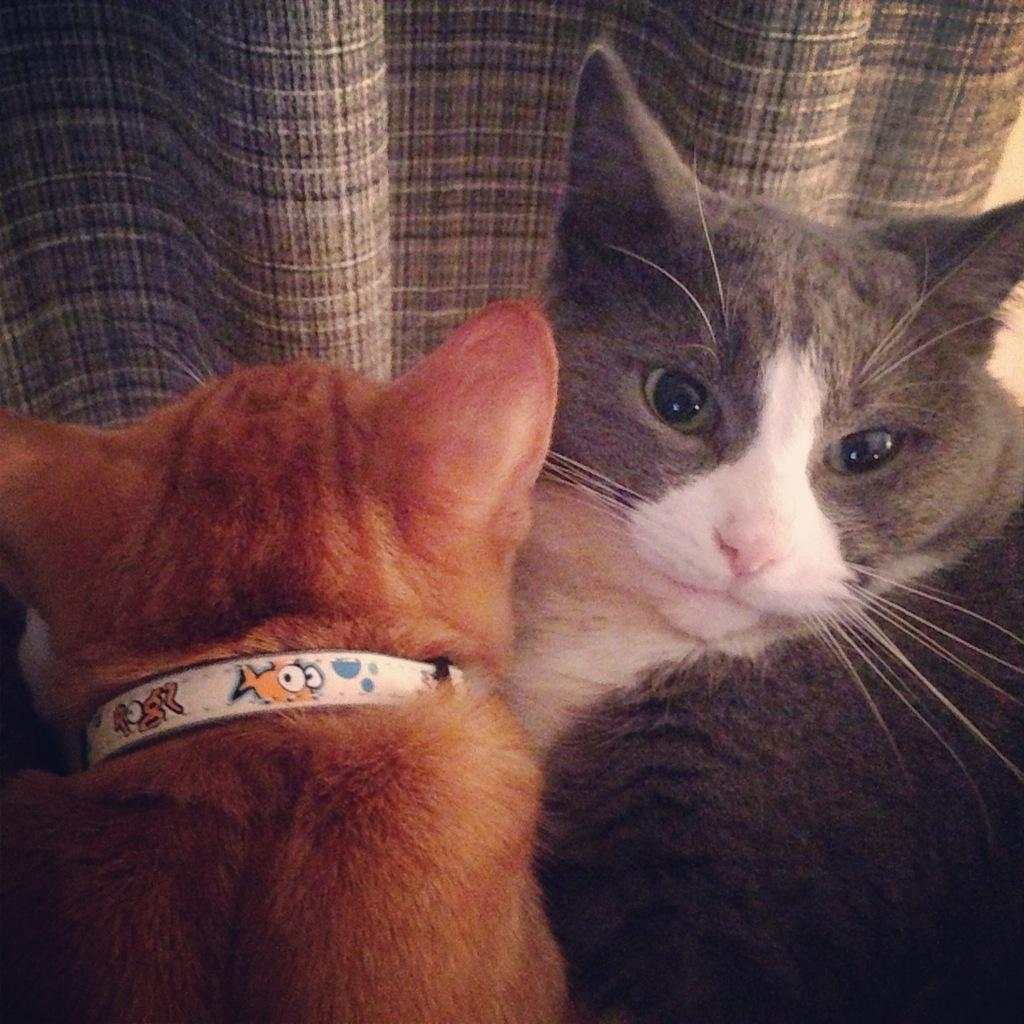What type of animals are in the image? There are cats in the image. What object is located at the top of the image? There is a cloth at the top of the image. What type of book is the cat reading in the image? There is no book or reading activity depicted in the image; the cats are simply present. What type of cup can be seen in the image? There is no cup present in the image. 